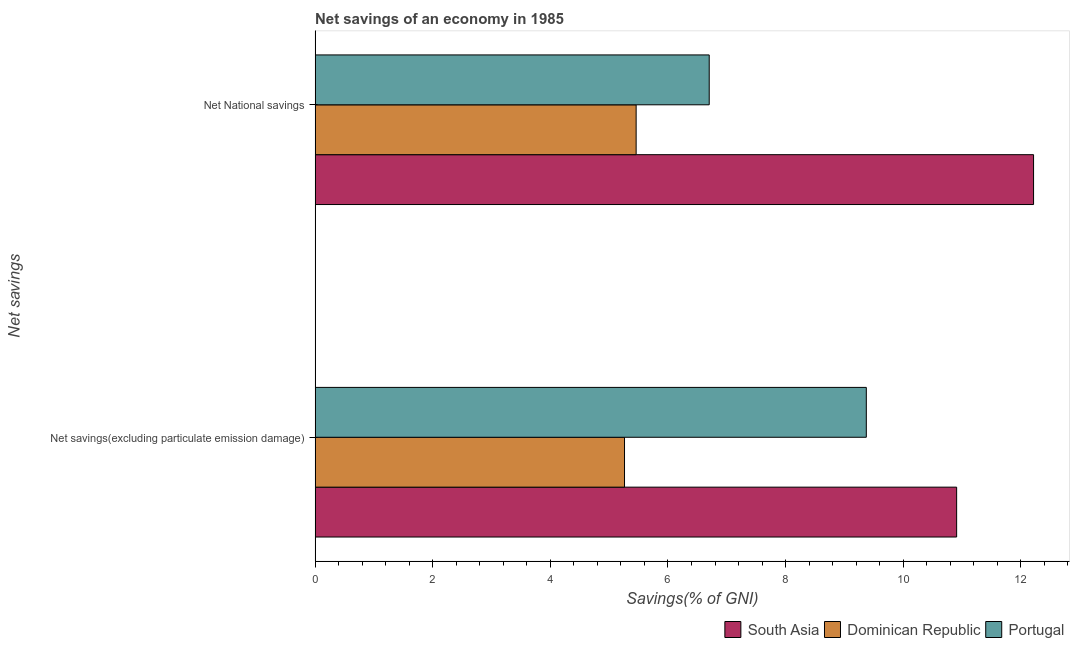How many groups of bars are there?
Your answer should be compact. 2. Are the number of bars on each tick of the Y-axis equal?
Your answer should be compact. Yes. What is the label of the 2nd group of bars from the top?
Your response must be concise. Net savings(excluding particulate emission damage). What is the net national savings in Portugal?
Your answer should be very brief. 6.7. Across all countries, what is the maximum net national savings?
Keep it short and to the point. 12.22. Across all countries, what is the minimum net savings(excluding particulate emission damage)?
Provide a succinct answer. 5.26. In which country was the net national savings maximum?
Offer a terse response. South Asia. In which country was the net savings(excluding particulate emission damage) minimum?
Provide a short and direct response. Dominican Republic. What is the total net savings(excluding particulate emission damage) in the graph?
Provide a short and direct response. 25.54. What is the difference between the net savings(excluding particulate emission damage) in Dominican Republic and that in Portugal?
Your response must be concise. -4.11. What is the difference between the net national savings in South Asia and the net savings(excluding particulate emission damage) in Dominican Republic?
Ensure brevity in your answer.  6.96. What is the average net national savings per country?
Make the answer very short. 8.13. What is the difference between the net savings(excluding particulate emission damage) and net national savings in Dominican Republic?
Ensure brevity in your answer.  -0.2. In how many countries, is the net national savings greater than 5.6 %?
Provide a short and direct response. 2. What is the ratio of the net national savings in South Asia to that in Dominican Republic?
Your answer should be very brief. 2.24. In how many countries, is the net savings(excluding particulate emission damage) greater than the average net savings(excluding particulate emission damage) taken over all countries?
Ensure brevity in your answer.  2. What does the 2nd bar from the top in Net National savings represents?
Give a very brief answer. Dominican Republic. What does the 3rd bar from the bottom in Net National savings represents?
Offer a terse response. Portugal. How many bars are there?
Make the answer very short. 6. Are all the bars in the graph horizontal?
Your answer should be compact. Yes. How many countries are there in the graph?
Your response must be concise. 3. What is the difference between two consecutive major ticks on the X-axis?
Your answer should be very brief. 2. Are the values on the major ticks of X-axis written in scientific E-notation?
Ensure brevity in your answer.  No. Where does the legend appear in the graph?
Your response must be concise. Bottom right. How many legend labels are there?
Offer a very short reply. 3. What is the title of the graph?
Provide a short and direct response. Net savings of an economy in 1985. Does "Algeria" appear as one of the legend labels in the graph?
Your response must be concise. No. What is the label or title of the X-axis?
Provide a short and direct response. Savings(% of GNI). What is the label or title of the Y-axis?
Ensure brevity in your answer.  Net savings. What is the Savings(% of GNI) in South Asia in Net savings(excluding particulate emission damage)?
Offer a terse response. 10.91. What is the Savings(% of GNI) in Dominican Republic in Net savings(excluding particulate emission damage)?
Your answer should be very brief. 5.26. What is the Savings(% of GNI) in Portugal in Net savings(excluding particulate emission damage)?
Provide a short and direct response. 9.37. What is the Savings(% of GNI) in South Asia in Net National savings?
Provide a succinct answer. 12.22. What is the Savings(% of GNI) in Dominican Republic in Net National savings?
Your answer should be compact. 5.46. What is the Savings(% of GNI) of Portugal in Net National savings?
Your response must be concise. 6.7. Across all Net savings, what is the maximum Savings(% of GNI) in South Asia?
Offer a terse response. 12.22. Across all Net savings, what is the maximum Savings(% of GNI) of Dominican Republic?
Your response must be concise. 5.46. Across all Net savings, what is the maximum Savings(% of GNI) in Portugal?
Ensure brevity in your answer.  9.37. Across all Net savings, what is the minimum Savings(% of GNI) of South Asia?
Make the answer very short. 10.91. Across all Net savings, what is the minimum Savings(% of GNI) of Dominican Republic?
Provide a short and direct response. 5.26. Across all Net savings, what is the minimum Savings(% of GNI) in Portugal?
Provide a succinct answer. 6.7. What is the total Savings(% of GNI) of South Asia in the graph?
Make the answer very short. 23.12. What is the total Savings(% of GNI) of Dominican Republic in the graph?
Offer a very short reply. 10.72. What is the total Savings(% of GNI) of Portugal in the graph?
Keep it short and to the point. 16.07. What is the difference between the Savings(% of GNI) in South Asia in Net savings(excluding particulate emission damage) and that in Net National savings?
Offer a terse response. -1.31. What is the difference between the Savings(% of GNI) in Dominican Republic in Net savings(excluding particulate emission damage) and that in Net National savings?
Give a very brief answer. -0.2. What is the difference between the Savings(% of GNI) of Portugal in Net savings(excluding particulate emission damage) and that in Net National savings?
Keep it short and to the point. 2.67. What is the difference between the Savings(% of GNI) of South Asia in Net savings(excluding particulate emission damage) and the Savings(% of GNI) of Dominican Republic in Net National savings?
Ensure brevity in your answer.  5.45. What is the difference between the Savings(% of GNI) of South Asia in Net savings(excluding particulate emission damage) and the Savings(% of GNI) of Portugal in Net National savings?
Ensure brevity in your answer.  4.21. What is the difference between the Savings(% of GNI) of Dominican Republic in Net savings(excluding particulate emission damage) and the Savings(% of GNI) of Portugal in Net National savings?
Keep it short and to the point. -1.44. What is the average Savings(% of GNI) in South Asia per Net savings?
Your response must be concise. 11.56. What is the average Savings(% of GNI) of Dominican Republic per Net savings?
Keep it short and to the point. 5.36. What is the average Savings(% of GNI) in Portugal per Net savings?
Give a very brief answer. 8.04. What is the difference between the Savings(% of GNI) of South Asia and Savings(% of GNI) of Dominican Republic in Net savings(excluding particulate emission damage)?
Your answer should be compact. 5.65. What is the difference between the Savings(% of GNI) of South Asia and Savings(% of GNI) of Portugal in Net savings(excluding particulate emission damage)?
Ensure brevity in your answer.  1.54. What is the difference between the Savings(% of GNI) in Dominican Republic and Savings(% of GNI) in Portugal in Net savings(excluding particulate emission damage)?
Your answer should be very brief. -4.11. What is the difference between the Savings(% of GNI) in South Asia and Savings(% of GNI) in Dominican Republic in Net National savings?
Your response must be concise. 6.76. What is the difference between the Savings(% of GNI) in South Asia and Savings(% of GNI) in Portugal in Net National savings?
Keep it short and to the point. 5.51. What is the difference between the Savings(% of GNI) of Dominican Republic and Savings(% of GNI) of Portugal in Net National savings?
Provide a short and direct response. -1.24. What is the ratio of the Savings(% of GNI) of South Asia in Net savings(excluding particulate emission damage) to that in Net National savings?
Ensure brevity in your answer.  0.89. What is the ratio of the Savings(% of GNI) in Dominican Republic in Net savings(excluding particulate emission damage) to that in Net National savings?
Provide a short and direct response. 0.96. What is the ratio of the Savings(% of GNI) of Portugal in Net savings(excluding particulate emission damage) to that in Net National savings?
Make the answer very short. 1.4. What is the difference between the highest and the second highest Savings(% of GNI) in South Asia?
Offer a very short reply. 1.31. What is the difference between the highest and the second highest Savings(% of GNI) of Dominican Republic?
Your answer should be very brief. 0.2. What is the difference between the highest and the second highest Savings(% of GNI) in Portugal?
Keep it short and to the point. 2.67. What is the difference between the highest and the lowest Savings(% of GNI) of South Asia?
Make the answer very short. 1.31. What is the difference between the highest and the lowest Savings(% of GNI) of Dominican Republic?
Provide a short and direct response. 0.2. What is the difference between the highest and the lowest Savings(% of GNI) of Portugal?
Keep it short and to the point. 2.67. 